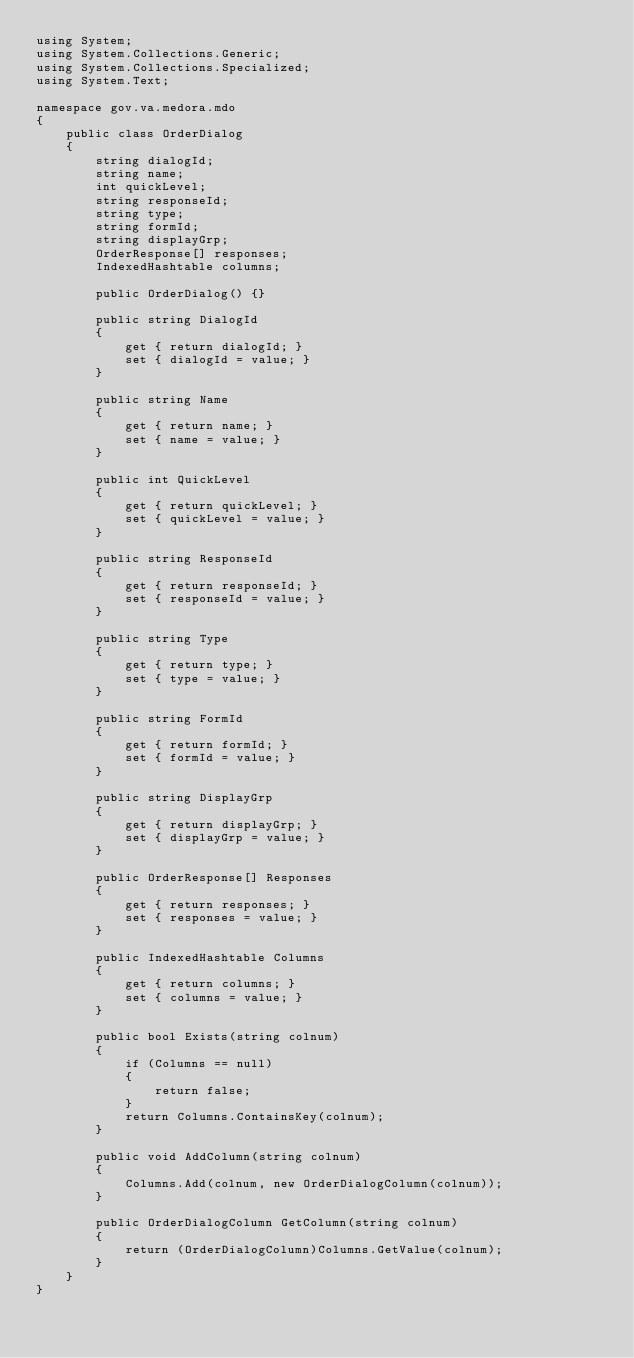<code> <loc_0><loc_0><loc_500><loc_500><_C#_>using System;
using System.Collections.Generic;
using System.Collections.Specialized;
using System.Text;

namespace gov.va.medora.mdo
{
    public class OrderDialog
    {
        string dialogId;
        string name;
        int quickLevel;
        string responseId;
        string type;
        string formId;
        string displayGrp;
        OrderResponse[] responses;
        IndexedHashtable columns;

        public OrderDialog() {}
        
        public string DialogId
        {
            get { return dialogId; }
            set { dialogId = value; }
        }

        public string Name
        {
            get { return name; }
            set { name = value; }
        }

        public int QuickLevel
        {
            get { return quickLevel; }
            set { quickLevel = value; }
        }

        public string ResponseId
        {
            get { return responseId; }
            set { responseId = value; }
        }

        public string Type
        {
            get { return type; }
            set { type = value; }
        }

        public string FormId
        {
            get { return formId; }
            set { formId = value; }
        }

        public string DisplayGrp
        {
            get { return displayGrp; }
            set { displayGrp = value; }
        }

        public OrderResponse[] Responses
        {
            get { return responses; }
            set { responses = value; }
        }

        public IndexedHashtable Columns
        {
            get { return columns; }
            set { columns = value; }
        }

        public bool Exists(string colnum)
        {
            if (Columns == null)
            {
                return false;
            }
            return Columns.ContainsKey(colnum);
        }

        public void AddColumn(string colnum)
        {
            Columns.Add(colnum, new OrderDialogColumn(colnum));
        }

        public OrderDialogColumn GetColumn(string colnum)
        {
            return (OrderDialogColumn)Columns.GetValue(colnum);
        }
    }
}
</code> 